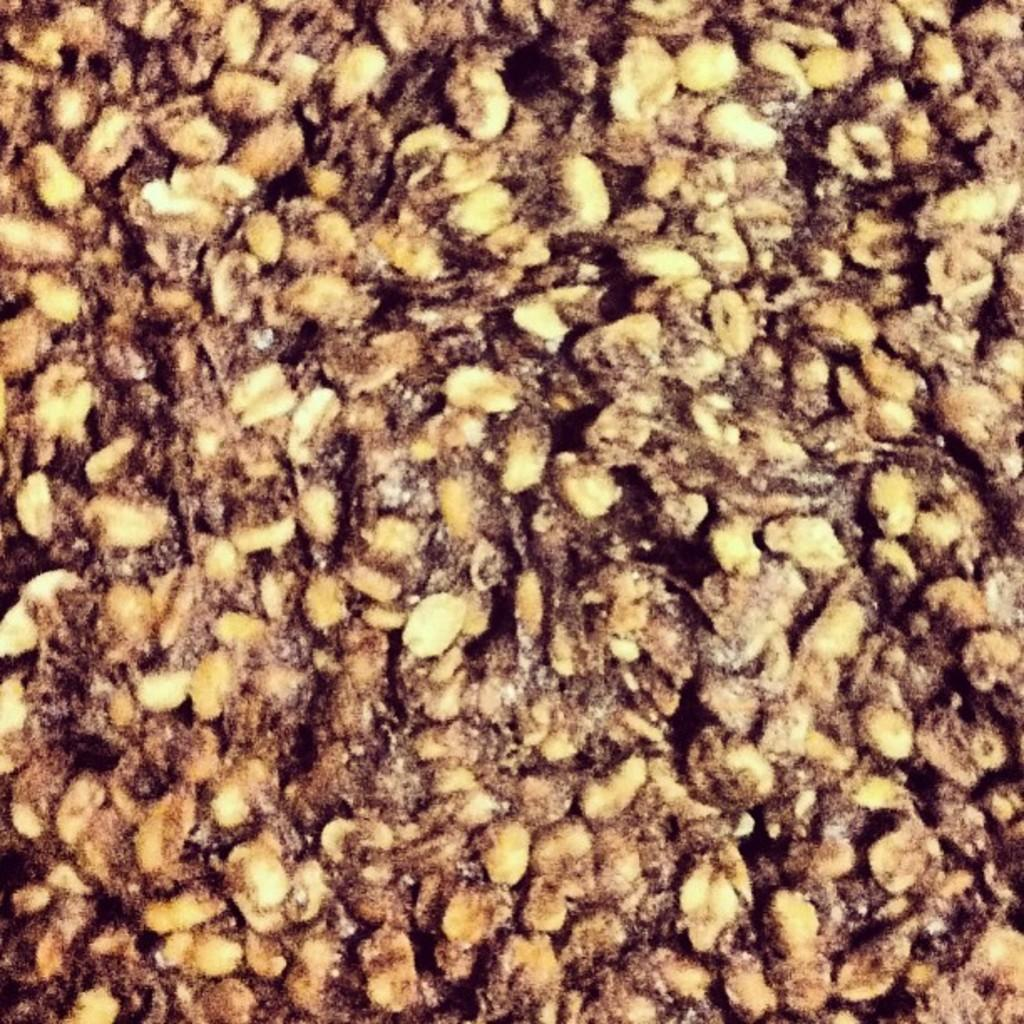What is the main subject of the image? The image appears to depict food. Is the ring on the daughter's finger visible in the image? There is no mention of a ring, a daughter, or a writer in the provided fact, so it cannot be determined if the ring is visible in the image. 